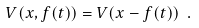Convert formula to latex. <formula><loc_0><loc_0><loc_500><loc_500>V ( x , f ( t ) ) = V ( x - f ( t ) ) \ .</formula> 